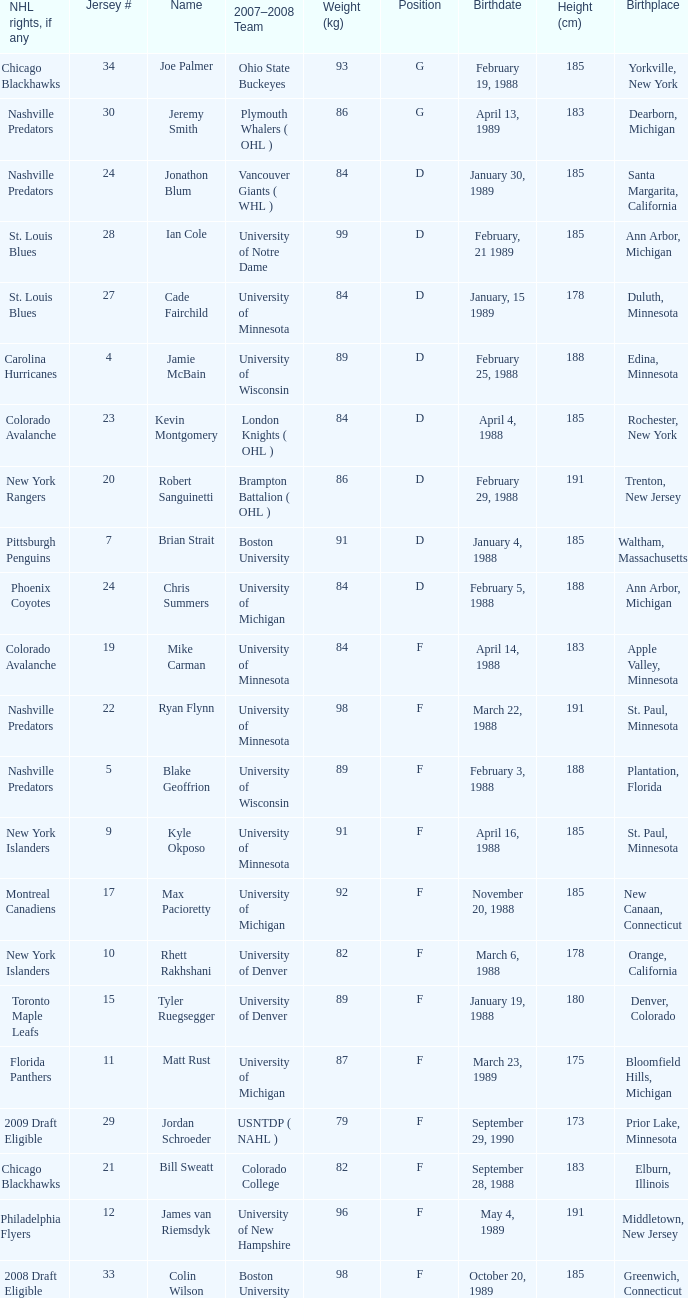Which height (cm) corresponds to a birthplace in bloomfield hills, michigan? 175.0. 